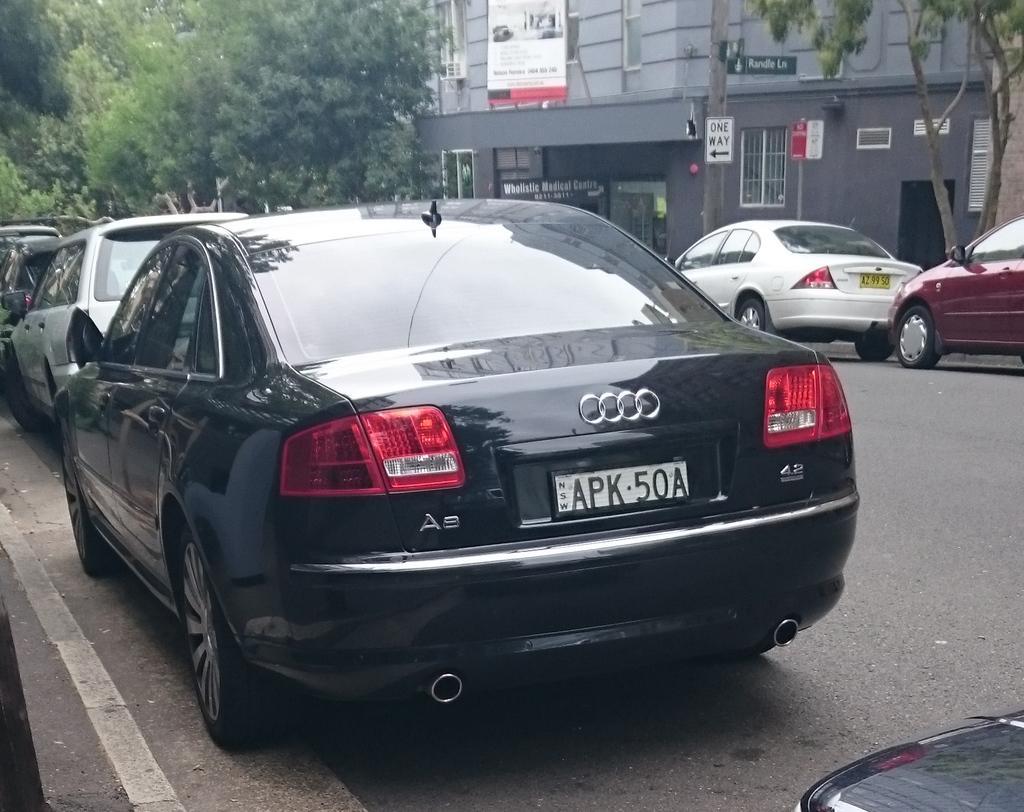Could you give a brief overview of what you see in this image? In this image I can see the cars parked on both sides of the road. I can see trees in the top right and left corners. I can see a building with some sign boards with some text. 